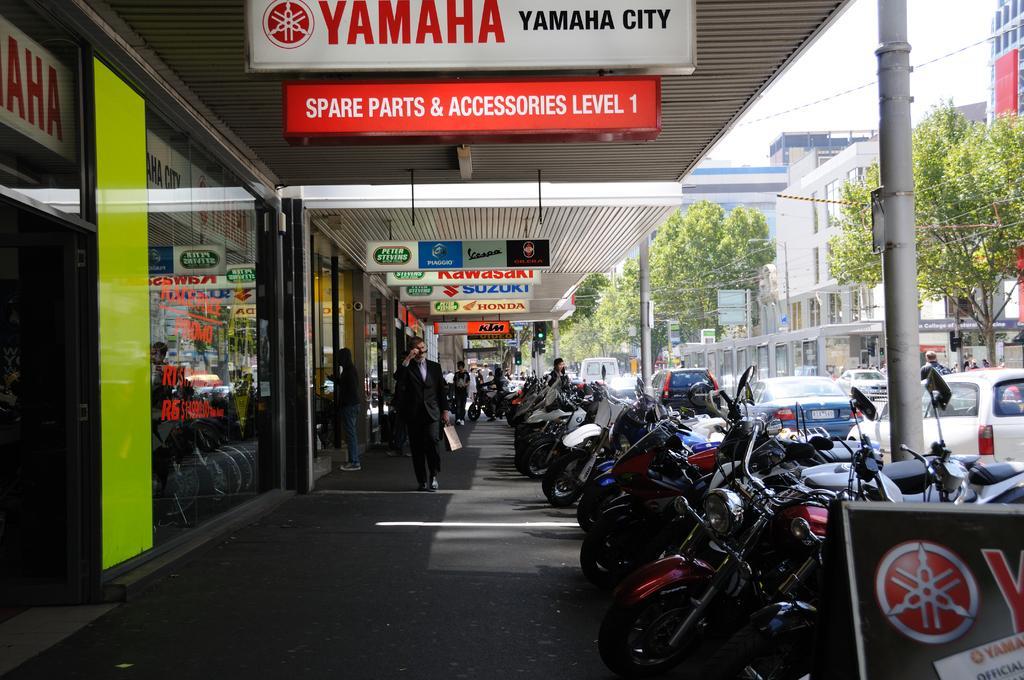Describe this image in one or two sentences. In the foreground of this image, on the right there are motor bikes, pole, a board and few vehicles moving on the road. On the left, there are glass walls, few boards, few people walking and standing on the path and there are few boards to the roof of the shed. In the background, there are trees, cables buildings and the sky. 